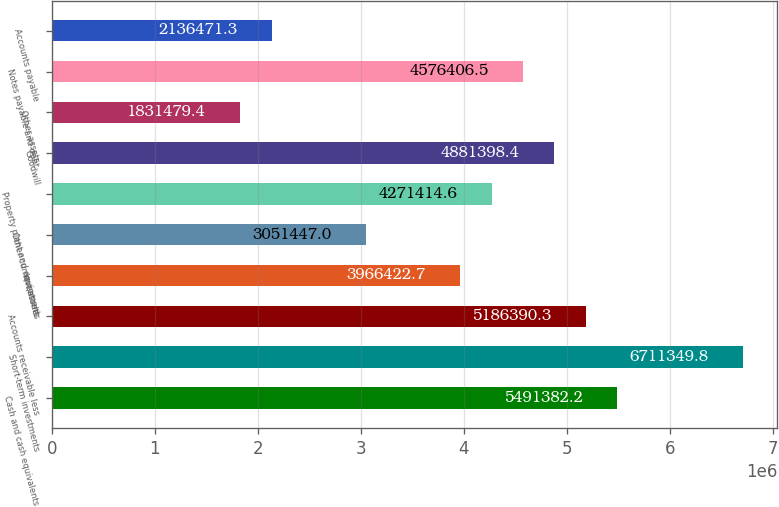<chart> <loc_0><loc_0><loc_500><loc_500><bar_chart><fcel>Cash and cash equivalents<fcel>Short-term investments<fcel>Accounts receivable less<fcel>Inventories<fcel>Other current assets<fcel>Property plant and equipment<fcel>Goodwill<fcel>Other assets<fcel>Notes payable and debt<fcel>Accounts payable<nl><fcel>5.49138e+06<fcel>6.71135e+06<fcel>5.18639e+06<fcel>3.96642e+06<fcel>3.05145e+06<fcel>4.27141e+06<fcel>4.8814e+06<fcel>1.83148e+06<fcel>4.57641e+06<fcel>2.13647e+06<nl></chart> 